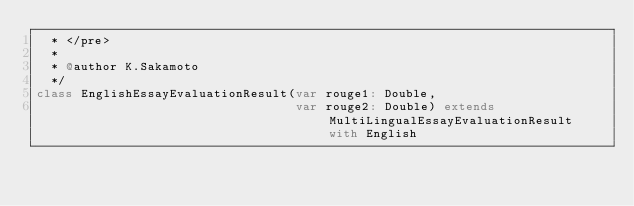Convert code to text. <code><loc_0><loc_0><loc_500><loc_500><_Scala_>  * </pre>
  *
  * @author K.Sakamoto
  */
class EnglishEssayEvaluationResult(var rouge1: Double,
                                   var rouge2: Double) extends MultiLingualEssayEvaluationResult with English
</code> 